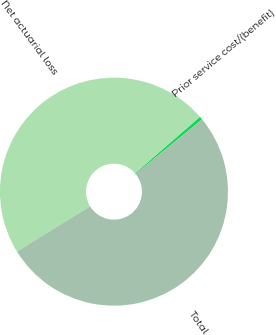<chart> <loc_0><loc_0><loc_500><loc_500><pie_chart><fcel>Prior service cost/(benefit)<fcel>Net actuarial loss<fcel>Total<nl><fcel>0.46%<fcel>47.4%<fcel>52.14%<nl></chart> 